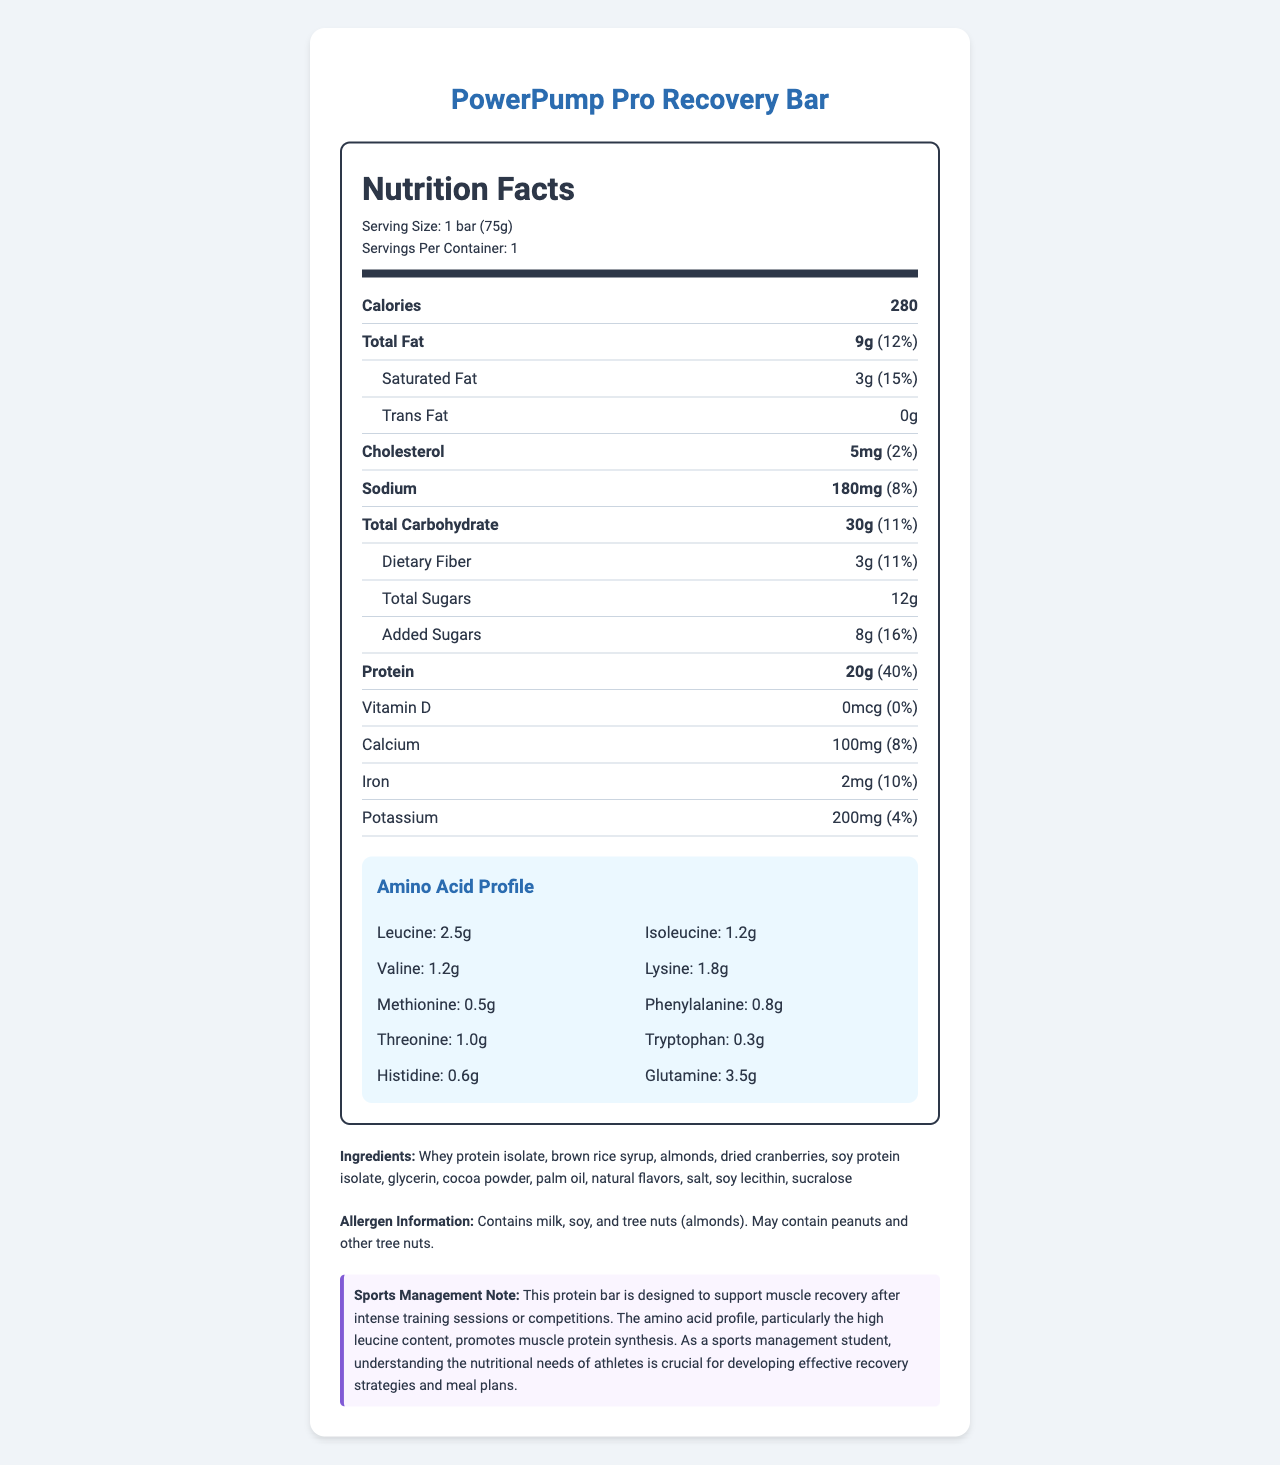How many grams of protein does the PowerPump Pro Recovery Bar contain? The document states that the protein content is 20 grams per bar.
Answer: 20g What is the serving size of the PowerPump Pro Recovery Bar? The serving size listed on the document is 1 bar (75g).
Answer: 1 bar (75g) Which two amino acids have the exact same amount in the amino acid profile? Both Isoleucine and Valine are listed with an amount of 1.2g.
Answer: Isoleucine and Valine What is the calorie content of the PowerPump Pro Recovery Bar? The document states that the bar contains 280 calories.
Answer: 280 calories How many grams of added sugars are in the bar? The document specifies that there are 8 grams of added sugars.
Answer: 8g Which nutrient has the highest daily value percentage in the PowerPump Pro Recovery Bar? A. Protein B. Total Fat C. Sodium D. Iron The protein content has a daily value of 40%, which is the highest among the listed nutrients.
Answer: A. Protein How much Leucine is present in the amino acid profile? A. 1.2g B. 2.5g C. 0.8g D. 3.5g The amino acid profile section indicates that there are 2.5 grams of Leucine.
Answer: B. 2.5g Does the PowerPump Pro Recovery Bar contain any tree nuts? The allergen information section states that the bar contains tree nuts (almonds).
Answer: Yes Summarize the main idea of the document. The document gives comprehensive nutritional details of the protein bar, highlighting its benefits for athletes and those engaged in intense physical activities.
Answer: The document provides detailed nutritional information for the PowerPump Pro Recovery Bar, which is designed for muscle recovery. It includes the serving size, calorie content, amounts of various nutrients, an amino acid profile, ingredients, and allergen information. The bar is high in protein and contains essential amino acids to support muscle recovery after intense training or competitions. What is the main source of protein in the PowerPump Pro Recovery Bar? The ingredients list mentions whey protein isolate as one of the primary sources of protein.
Answer: Whey protein isolate What percentage of daily value of calcium does this protein bar provide? The document lists the calcium content as providing 8% of the daily value.
Answer: 8% How much Glutamine is present in the PowerPump Pro Recovery Bar? The amino acid profile section states there are 3.5 grams of Glutamine.
Answer: 3.5g What is the total carbohydrate content of the PowerPump Pro Recovery Bar? The document lists the total carbohydrate content as 30 grams.
Answer: 30g Does the PowerPump Pro Recovery Bar contain any cholesterol? The document states that the bar contains 5mg of cholesterol, which is 2% of the daily value.
Answer: Yes How many servings are in one container of the PowerPump Pro Recovery Bar? The document mentions that there is one serving per container.
Answer: 1 How much Vitamin D does the PowerPump Pro Recovery Bar contain? The Vitamin D content is listed as 0mcg.
Answer: 0mcg What are the allergen warnings associated with this protein bar? The document provides allergen information stating that it contains milk, soy, and tree nuts (almonds), and it may also contain peanuts and other tree nuts.
Answer: Contains milk, soy, and tree nuts (almonds). May contain peanuts and other tree nuts. Is the potassium content higher than the calcium content in the PowerPump Pro Recovery Bar? The document indicates that the calcium content is 100mg (8% DV), while the potassium content is 200mg (4% DV), so the potassium content is higher, not lower.
Answer: No What is the price of the PowerPump Pro Recovery Bar? The document does not provide any information on the price of the protein bar.
Answer: Cannot be determined 